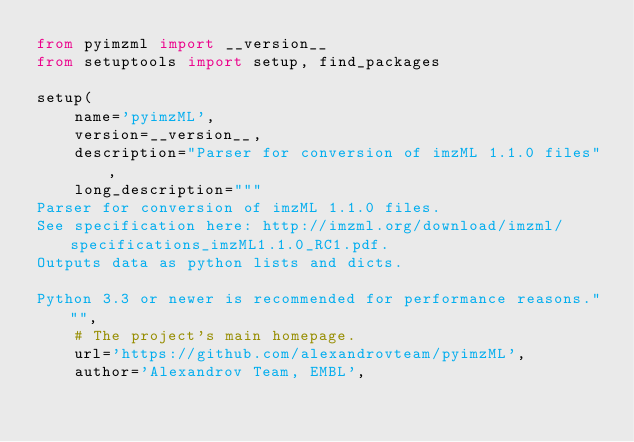<code> <loc_0><loc_0><loc_500><loc_500><_Python_>from pyimzml import __version__
from setuptools import setup, find_packages

setup(
    name='pyimzML',
    version=__version__,
    description="Parser for conversion of imzML 1.1.0 files",
    long_description="""
Parser for conversion of imzML 1.1.0 files.
See specification here: http://imzml.org/download/imzml/specifications_imzML1.1.0_RC1.pdf.
Outputs data as python lists and dicts.

Python 3.3 or newer is recommended for performance reasons.""",
    # The project's main homepage.
    url='https://github.com/alexandrovteam/pyimzML',
    author='Alexandrov Team, EMBL',</code> 